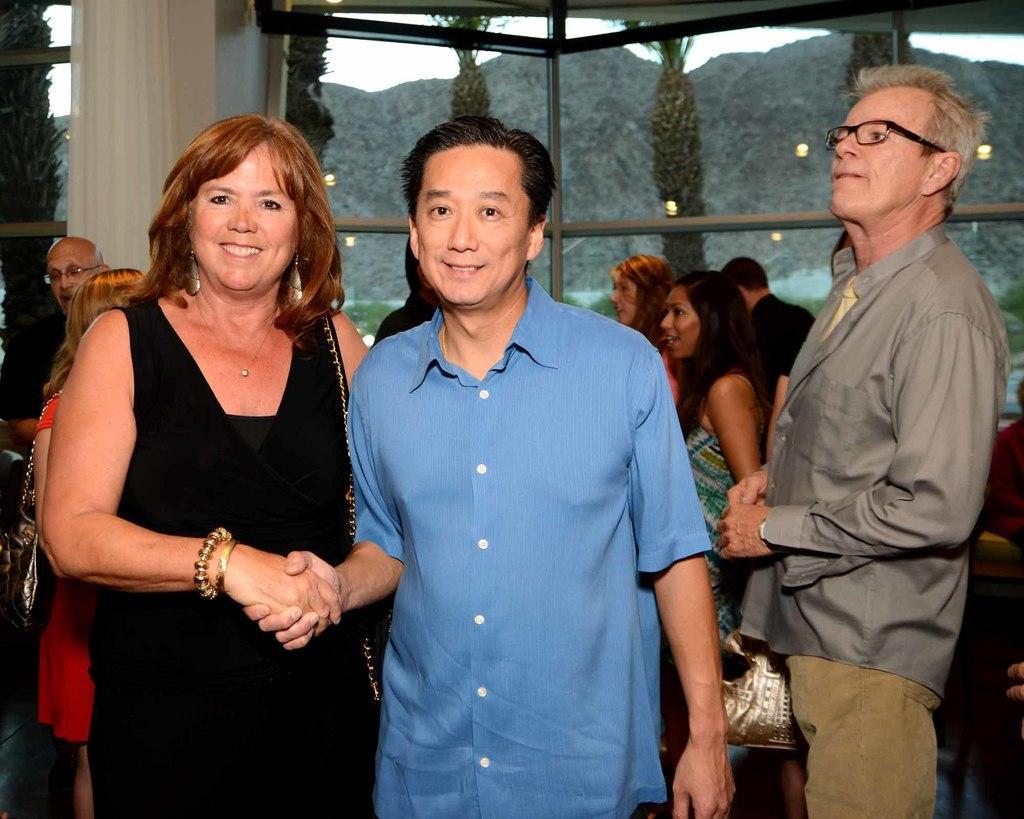Could you give a brief overview of what you see in this image? In this image, we can see a woman and man are shaking their hands each other. They are watching and smiling. Background we can see few people. Here a person is standing we can see on the right side of the image. Here we can see glass objects, pillars, curtain. Through the glass we can see trees, hills, plants and sky. 